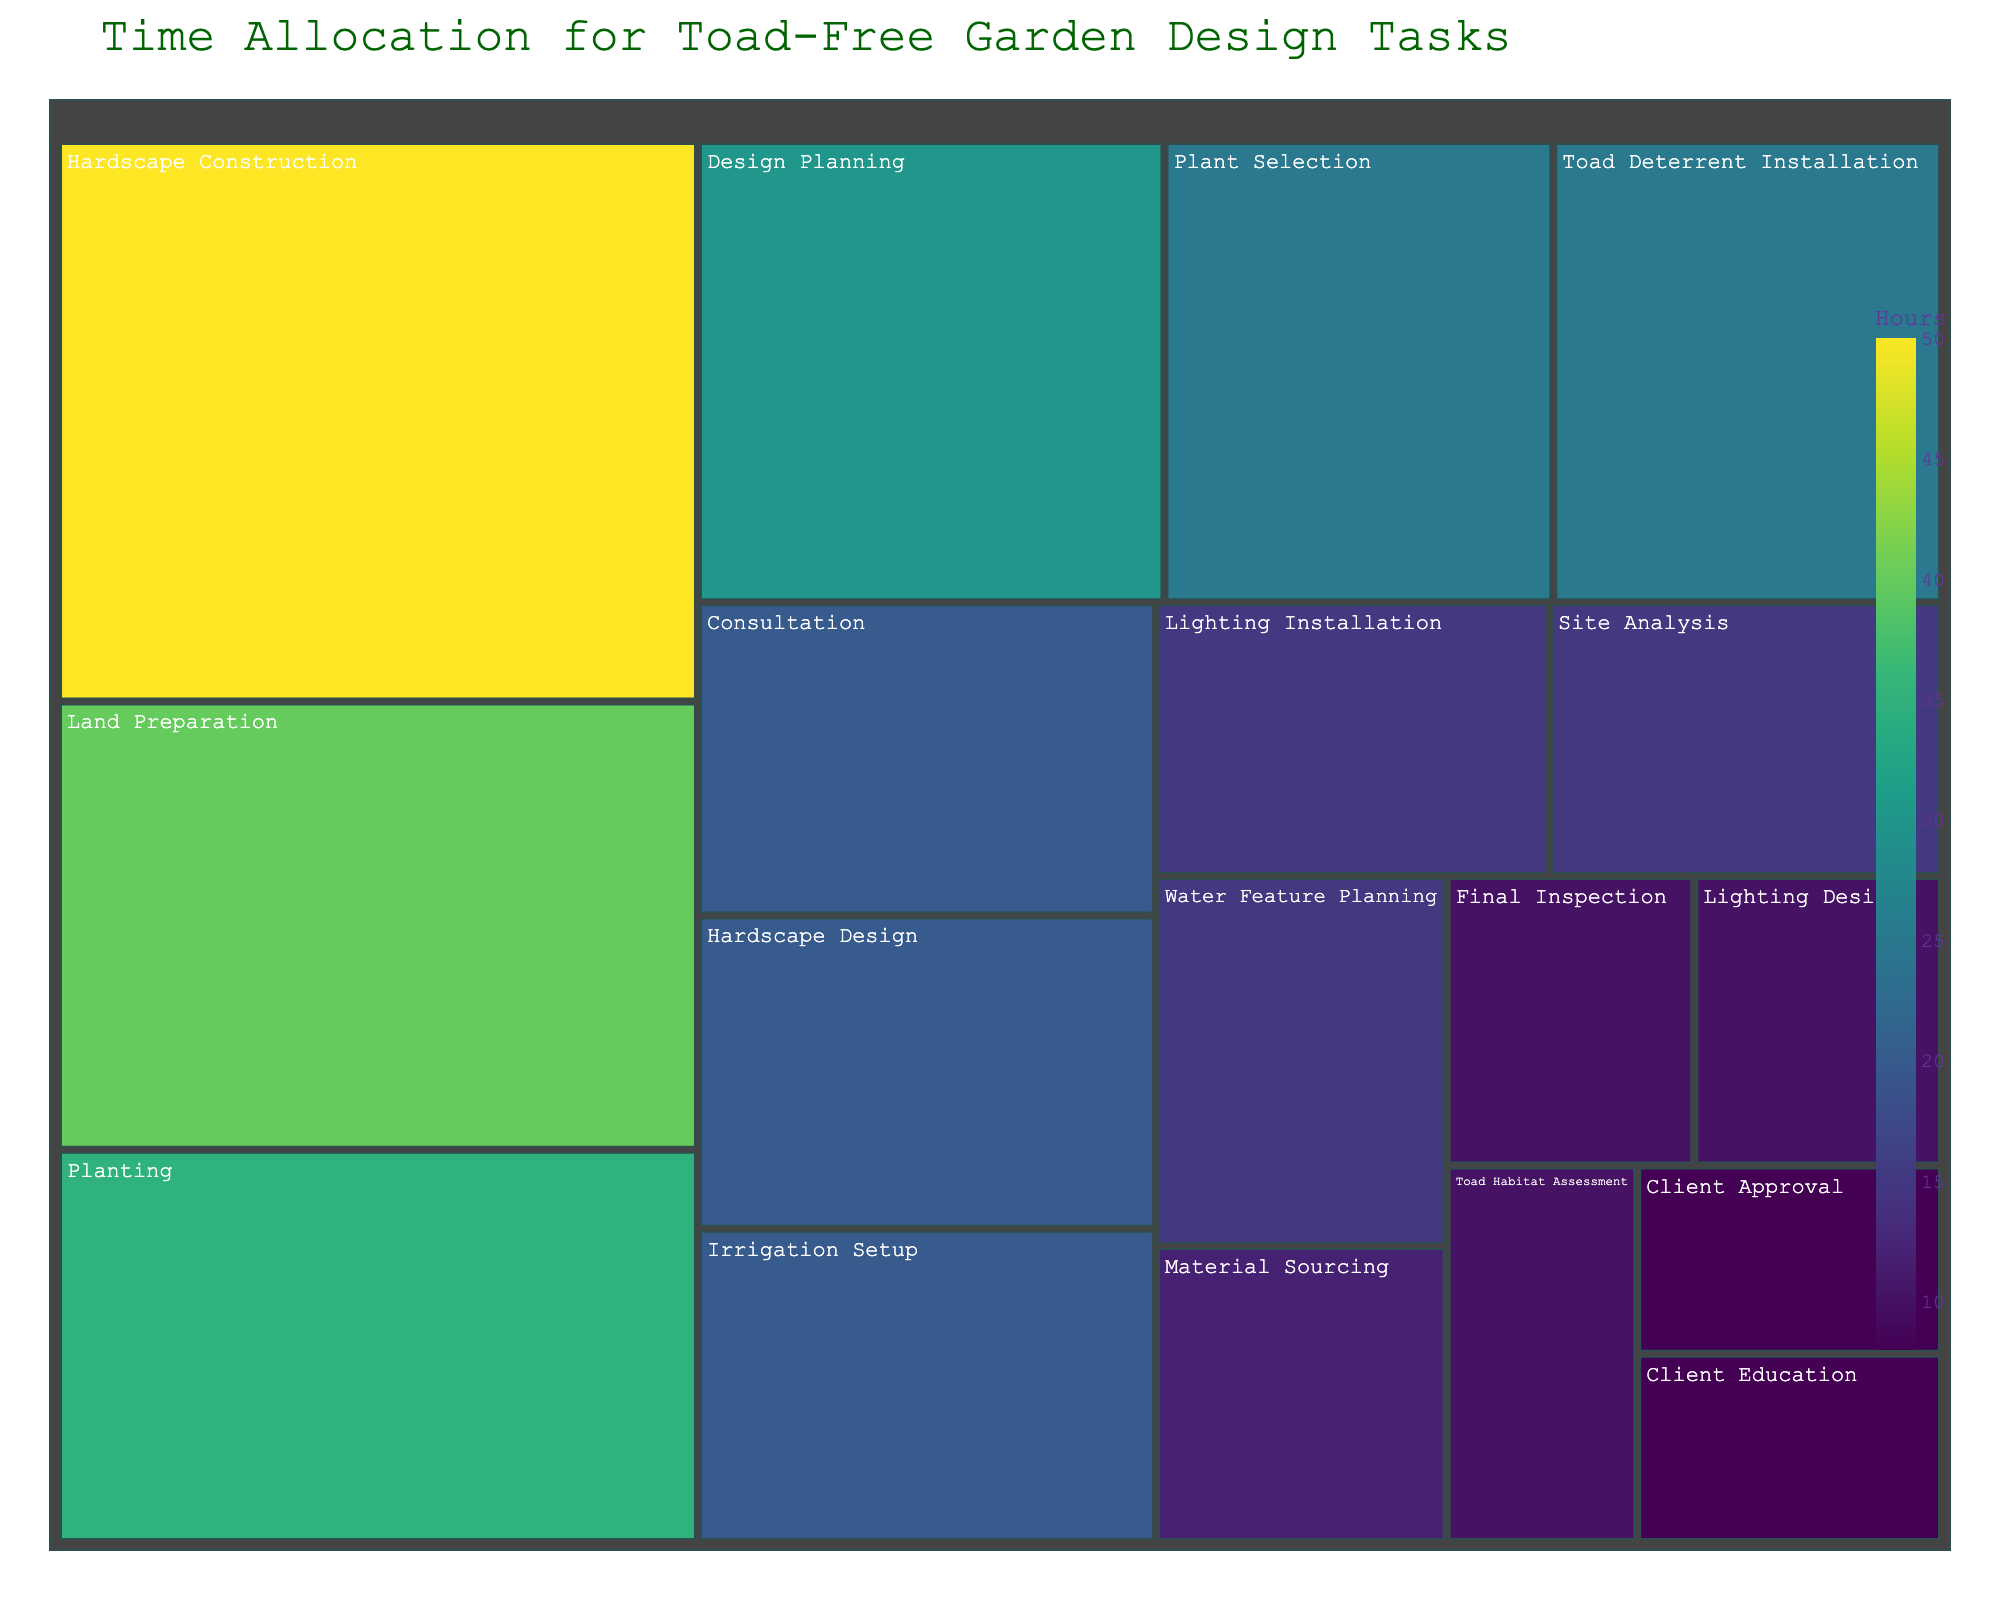What is the title of the treemap? The title is usually located at the top of the plot and provides a summary of what the figure represents. In this case, it should give an idea about how time is allocated over various tasks in garden design.
Answer: Time Allocation for Toad-Free Garden Design Tasks How many tasks are included in the treemap? By looking at the different sections of the treemap, one can count the number of distinct tasks that are represented by different colors and areas.
Answer: 18 Which task takes the most hours? By observing the size of the sections in the treemap, the task with the largest area represents the one that has the highest number of hours allocated.
Answer: Hardscape Construction What is the total time spent on Site Analysis and Toad Habitat Assessment combined? Sum the hours for both Site Analysis and Toad Habitat Assessment as listed in the sections of the treemap.
Answer: 25 (15 + 10) Between Plant Selection and Irrigation Setup, which task is allocated more hours? Compare the size of the sections for Plant Selection and Irrigation Setup; the one with the larger area has more hours.
Answer: Plant Selection How many tasks take 20 hours or more? Look for the sections in the treemap that represent 20 or more hours and count them.
Answer: 7 What is the sum of hours allocated to all the tasks related to planning (Design Planning, Hardscape Design, Water Feature Planning, Lighting Design)? Add the hours for all the planning-related tasks by looking at their respective sections.
Answer: 75 (30 + 20 + 15 + 10) What is the average number of hours spent on consultation, site analysis, and client approval? Add the hours for Consultation, Site Analysis, and Client Approval, then divide by the number of these tasks.
Answer: 14.33 (20 + 15 + 8) / 3 Which takes more time, Land Preparation or the combined time of Planting and Toad Deterrent Installation? Compare the hours of Land Preparation directly to the sum of hours for Planting and Toad Deterrent Installation.
Answer: Planting and Toad Deterrent Installation (35 + 25 = 60 > 40) Which task related to installation has the lowest hours allocated to it? Identify the installation-related tasks (Toad Deterrent Installation, Irrigation Setup, Lighting Installation) and pick the one with the smallest value.
Answer: Lighting Installation 